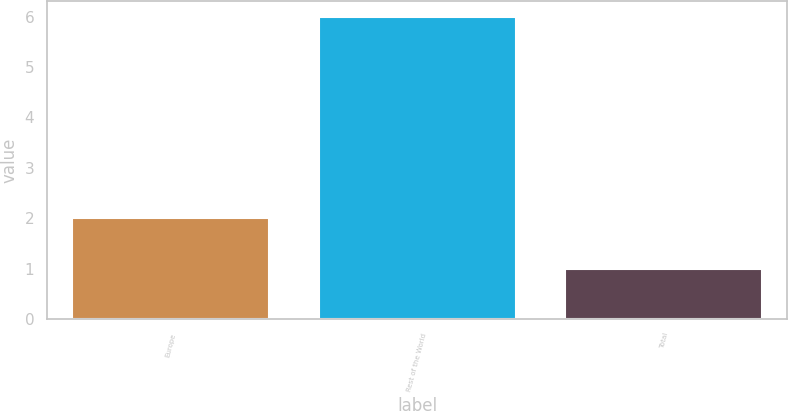Convert chart to OTSL. <chart><loc_0><loc_0><loc_500><loc_500><bar_chart><fcel>Europe<fcel>Rest of the World<fcel>Total<nl><fcel>2<fcel>6<fcel>1<nl></chart> 